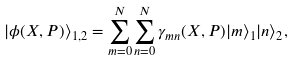Convert formula to latex. <formula><loc_0><loc_0><loc_500><loc_500>| \phi ( X , P ) \rangle _ { 1 , 2 } = \sum _ { m = 0 } ^ { N } \sum _ { n = 0 } ^ { N } \gamma _ { m n } ( X , P ) | m \rangle _ { 1 } | n \rangle _ { 2 } ,</formula> 